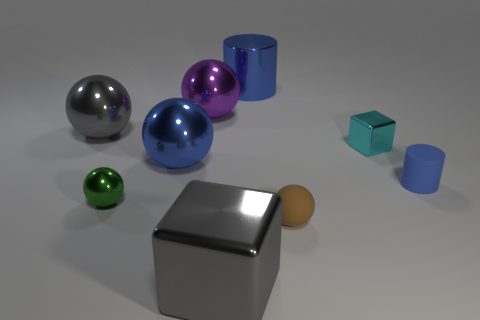What time of day do you think this scene represents? Considering the neutral lighting and lack of natural light sources or shadows indicating a sun position, this scene could represent any time of day. It appears to be artificially lit as if it is in an indoor environment or a studio setting. 